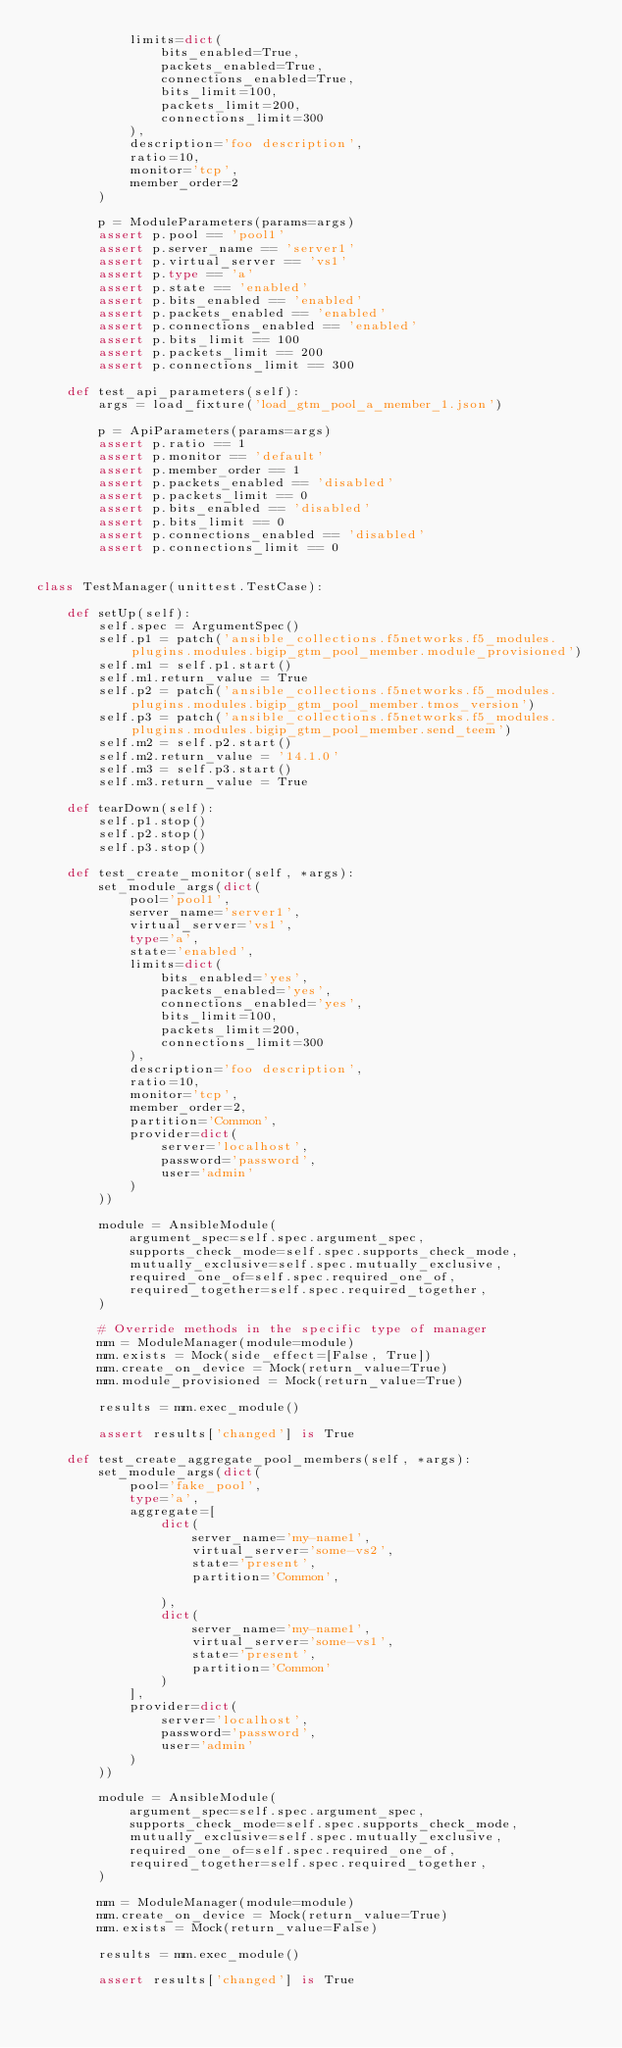<code> <loc_0><loc_0><loc_500><loc_500><_Python_>            limits=dict(
                bits_enabled=True,
                packets_enabled=True,
                connections_enabled=True,
                bits_limit=100,
                packets_limit=200,
                connections_limit=300
            ),
            description='foo description',
            ratio=10,
            monitor='tcp',
            member_order=2
        )

        p = ModuleParameters(params=args)
        assert p.pool == 'pool1'
        assert p.server_name == 'server1'
        assert p.virtual_server == 'vs1'
        assert p.type == 'a'
        assert p.state == 'enabled'
        assert p.bits_enabled == 'enabled'
        assert p.packets_enabled == 'enabled'
        assert p.connections_enabled == 'enabled'
        assert p.bits_limit == 100
        assert p.packets_limit == 200
        assert p.connections_limit == 300

    def test_api_parameters(self):
        args = load_fixture('load_gtm_pool_a_member_1.json')

        p = ApiParameters(params=args)
        assert p.ratio == 1
        assert p.monitor == 'default'
        assert p.member_order == 1
        assert p.packets_enabled == 'disabled'
        assert p.packets_limit == 0
        assert p.bits_enabled == 'disabled'
        assert p.bits_limit == 0
        assert p.connections_enabled == 'disabled'
        assert p.connections_limit == 0


class TestManager(unittest.TestCase):

    def setUp(self):
        self.spec = ArgumentSpec()
        self.p1 = patch('ansible_collections.f5networks.f5_modules.plugins.modules.bigip_gtm_pool_member.module_provisioned')
        self.m1 = self.p1.start()
        self.m1.return_value = True
        self.p2 = patch('ansible_collections.f5networks.f5_modules.plugins.modules.bigip_gtm_pool_member.tmos_version')
        self.p3 = patch('ansible_collections.f5networks.f5_modules.plugins.modules.bigip_gtm_pool_member.send_teem')
        self.m2 = self.p2.start()
        self.m2.return_value = '14.1.0'
        self.m3 = self.p3.start()
        self.m3.return_value = True

    def tearDown(self):
        self.p1.stop()
        self.p2.stop()
        self.p3.stop()

    def test_create_monitor(self, *args):
        set_module_args(dict(
            pool='pool1',
            server_name='server1',
            virtual_server='vs1',
            type='a',
            state='enabled',
            limits=dict(
                bits_enabled='yes',
                packets_enabled='yes',
                connections_enabled='yes',
                bits_limit=100,
                packets_limit=200,
                connections_limit=300
            ),
            description='foo description',
            ratio=10,
            monitor='tcp',
            member_order=2,
            partition='Common',
            provider=dict(
                server='localhost',
                password='password',
                user='admin'
            )
        ))

        module = AnsibleModule(
            argument_spec=self.spec.argument_spec,
            supports_check_mode=self.spec.supports_check_mode,
            mutually_exclusive=self.spec.mutually_exclusive,
            required_one_of=self.spec.required_one_of,
            required_together=self.spec.required_together,
        )

        # Override methods in the specific type of manager
        mm = ModuleManager(module=module)
        mm.exists = Mock(side_effect=[False, True])
        mm.create_on_device = Mock(return_value=True)
        mm.module_provisioned = Mock(return_value=True)

        results = mm.exec_module()

        assert results['changed'] is True

    def test_create_aggregate_pool_members(self, *args):
        set_module_args(dict(
            pool='fake_pool',
            type='a',
            aggregate=[
                dict(
                    server_name='my-name1',
                    virtual_server='some-vs2',
                    state='present',
                    partition='Common',

                ),
                dict(
                    server_name='my-name1',
                    virtual_server='some-vs1',
                    state='present',
                    partition='Common'
                )
            ],
            provider=dict(
                server='localhost',
                password='password',
                user='admin'
            )
        ))

        module = AnsibleModule(
            argument_spec=self.spec.argument_spec,
            supports_check_mode=self.spec.supports_check_mode,
            mutually_exclusive=self.spec.mutually_exclusive,
            required_one_of=self.spec.required_one_of,
            required_together=self.spec.required_together,
        )

        mm = ModuleManager(module=module)
        mm.create_on_device = Mock(return_value=True)
        mm.exists = Mock(return_value=False)

        results = mm.exec_module()

        assert results['changed'] is True
</code> 